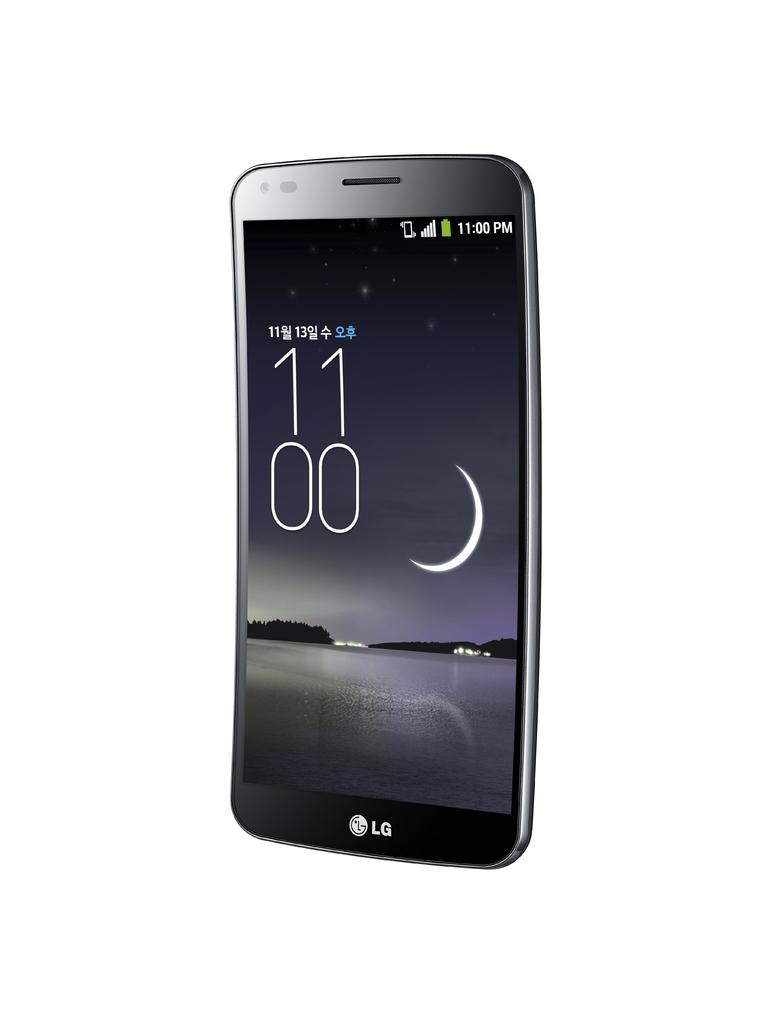<image>
Write a terse but informative summary of the picture. A curved black LG smart phone is against a white back drop. 